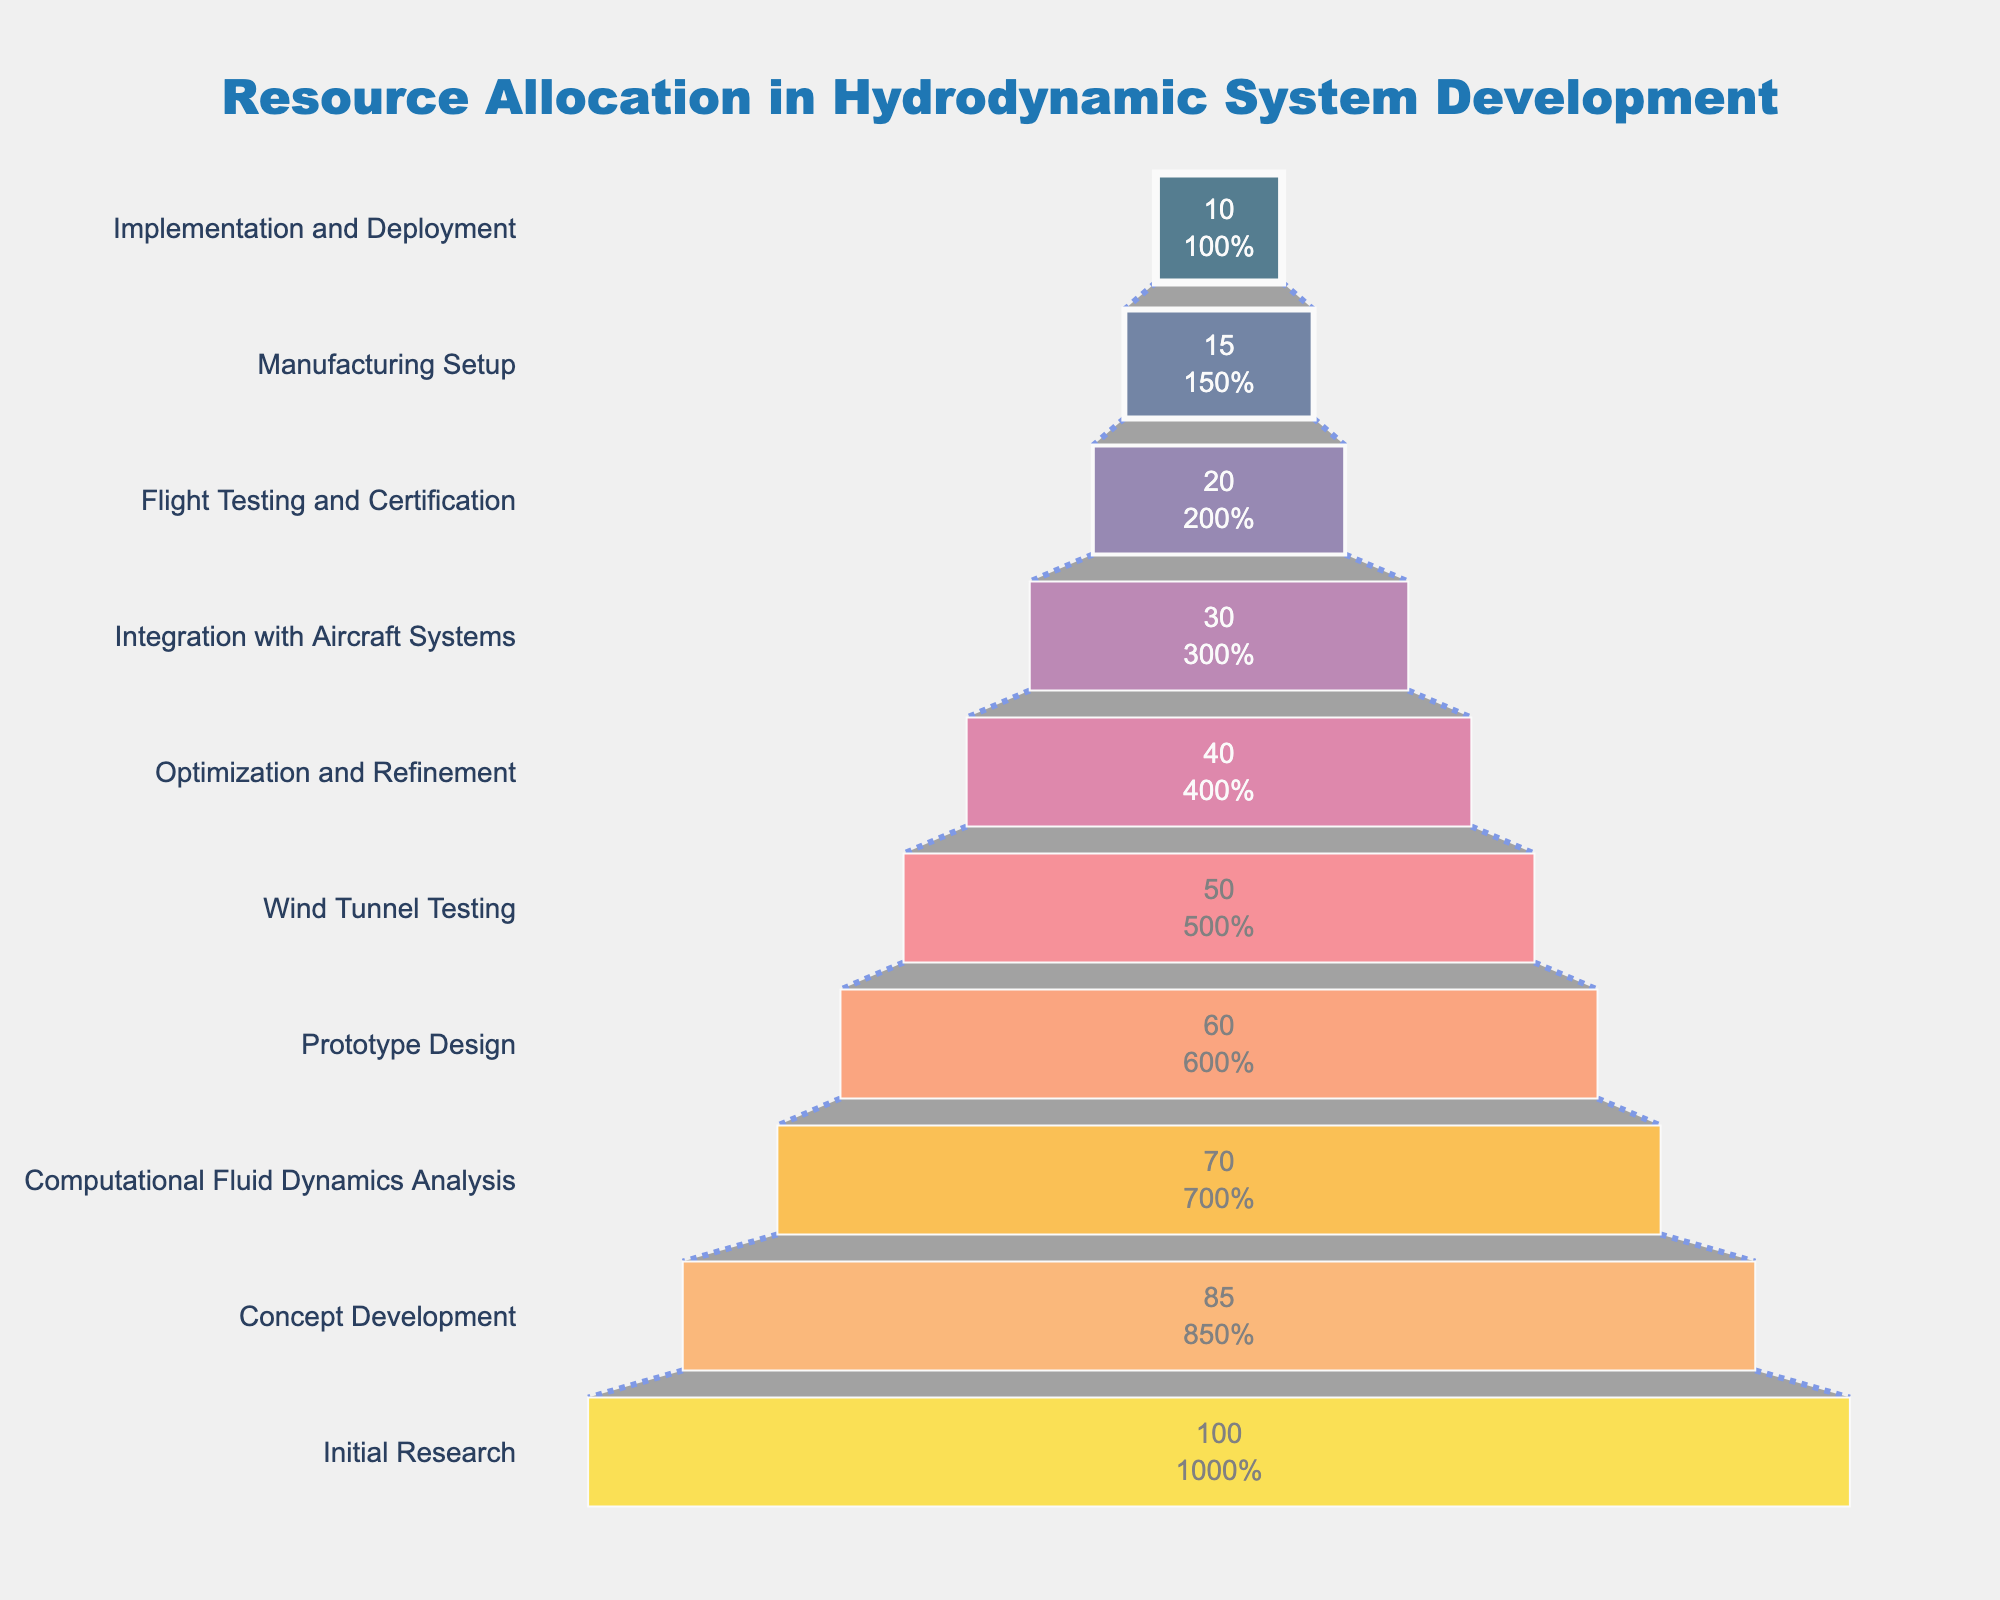What is the title of the chart? The title is centrally positioned at the top of the chart in a larger, bold font.
Answer: Resource Allocation in Hydrodynamic System Development How many stages are listed in the funnel chart? By counting each stage name along the y-axis, you can determine the total number.
Answer: 10 Which stage has the highest percentage of resource allocation? The stage at the widest part at the top of the funnel chart indicates the highest allocation.
Answer: Initial Research What is the resource allocation percentage for the 'Prototype Design' stage? Locate the 'Prototype Design' stage along the y-axis and read the corresponding percentage on the x-axis.
Answer: 60% By how much does the percentage decrease from 'Wind Tunnel Testing' to 'Manufacturing Setup'? Find the percentages for both stages ('Wind Tunnel Testing' = 50%, 'Manufacturing Setup' = 15%) and calculate the difference. 50% - 15% = 35%
Answer: 35% Which stage has the closest percentage to 50%, and does it lie above or below 50%? Identify the stage percentages around 50% to determine the closest one and note if it’s above or below. 'Wind Tunnel Testing' is exactly 50%.
Answer: Wind Tunnel Testing, equal to 50% Is the percentage of resources allocated for 'Optimization and Refinement' greater than or less than for 'Flight Testing and Certification'? Compare the resource percentages of 'Optimization and Refinement' (40%) and 'Flight Testing and Certification' (20%).
Answer: Greater than What percentage of resources is allocated for the last stage, 'Implementation and Deployment'? Locate the percentage for 'Implementation and Deployment' at the narrow end of the funnel.
Answer: 10% Which stage shows a 30% decrease in resource allocation from the previous stage? Identify the stage transitions where the resource allocation percentage drops by 30%. From 'Initial Research' (100%) to 'Concept Development' (70%).
Answer: Concept Development What two stages have a resource allocation difference of 20%? Find stages with values differing by 20%. Examples include 'Integration with Aircraft Systems' (30%) and 'Flight Testing and Certification' (20%).
Answer: Integration with Aircraft Systems and Flight Testing and Certification 